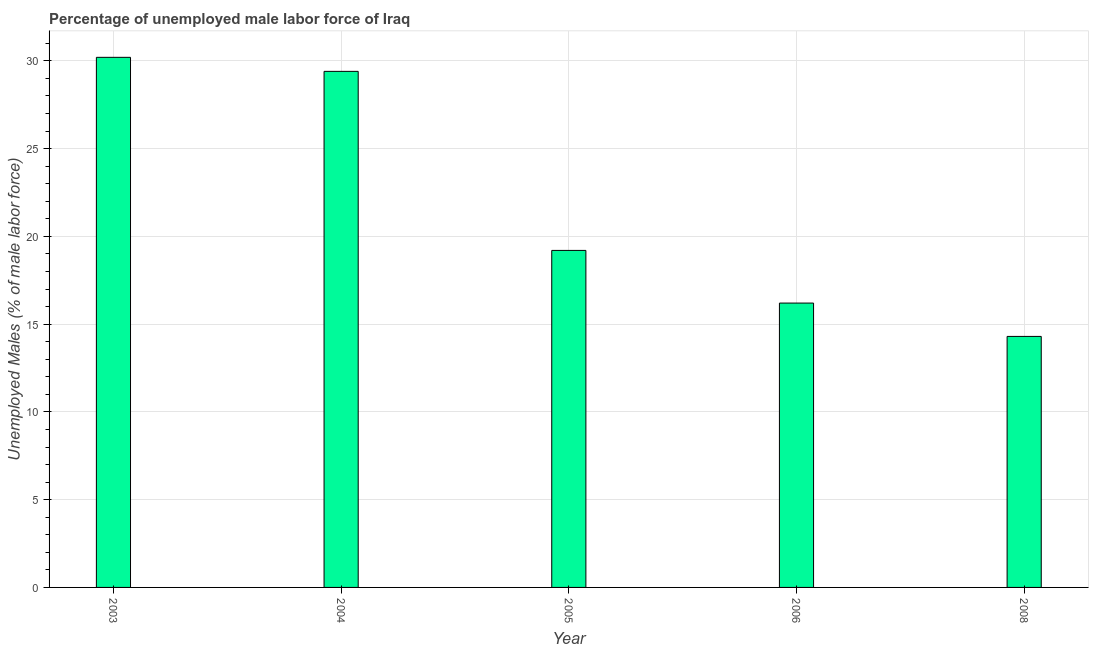Does the graph contain any zero values?
Offer a terse response. No. What is the title of the graph?
Provide a short and direct response. Percentage of unemployed male labor force of Iraq. What is the label or title of the Y-axis?
Ensure brevity in your answer.  Unemployed Males (% of male labor force). What is the total unemployed male labour force in 2006?
Provide a succinct answer. 16.2. Across all years, what is the maximum total unemployed male labour force?
Your answer should be compact. 30.2. Across all years, what is the minimum total unemployed male labour force?
Your response must be concise. 14.3. In which year was the total unemployed male labour force maximum?
Provide a succinct answer. 2003. What is the sum of the total unemployed male labour force?
Your answer should be compact. 109.3. What is the average total unemployed male labour force per year?
Your answer should be very brief. 21.86. What is the median total unemployed male labour force?
Provide a succinct answer. 19.2. What is the ratio of the total unemployed male labour force in 2004 to that in 2008?
Your answer should be very brief. 2.06. What is the difference between the highest and the second highest total unemployed male labour force?
Make the answer very short. 0.8. In how many years, is the total unemployed male labour force greater than the average total unemployed male labour force taken over all years?
Make the answer very short. 2. How many bars are there?
Your answer should be compact. 5. Are the values on the major ticks of Y-axis written in scientific E-notation?
Offer a very short reply. No. What is the Unemployed Males (% of male labor force) in 2003?
Provide a short and direct response. 30.2. What is the Unemployed Males (% of male labor force) in 2004?
Your answer should be compact. 29.4. What is the Unemployed Males (% of male labor force) in 2005?
Provide a succinct answer. 19.2. What is the Unemployed Males (% of male labor force) of 2006?
Make the answer very short. 16.2. What is the Unemployed Males (% of male labor force) of 2008?
Keep it short and to the point. 14.3. What is the difference between the Unemployed Males (% of male labor force) in 2003 and 2006?
Offer a terse response. 14. What is the difference between the Unemployed Males (% of male labor force) in 2004 and 2005?
Give a very brief answer. 10.2. What is the difference between the Unemployed Males (% of male labor force) in 2004 and 2006?
Give a very brief answer. 13.2. What is the difference between the Unemployed Males (% of male labor force) in 2004 and 2008?
Provide a short and direct response. 15.1. What is the difference between the Unemployed Males (% of male labor force) in 2005 and 2008?
Offer a very short reply. 4.9. What is the difference between the Unemployed Males (% of male labor force) in 2006 and 2008?
Make the answer very short. 1.9. What is the ratio of the Unemployed Males (% of male labor force) in 2003 to that in 2004?
Ensure brevity in your answer.  1.03. What is the ratio of the Unemployed Males (% of male labor force) in 2003 to that in 2005?
Your answer should be compact. 1.57. What is the ratio of the Unemployed Males (% of male labor force) in 2003 to that in 2006?
Your response must be concise. 1.86. What is the ratio of the Unemployed Males (% of male labor force) in 2003 to that in 2008?
Provide a short and direct response. 2.11. What is the ratio of the Unemployed Males (% of male labor force) in 2004 to that in 2005?
Ensure brevity in your answer.  1.53. What is the ratio of the Unemployed Males (% of male labor force) in 2004 to that in 2006?
Your answer should be very brief. 1.81. What is the ratio of the Unemployed Males (% of male labor force) in 2004 to that in 2008?
Your answer should be very brief. 2.06. What is the ratio of the Unemployed Males (% of male labor force) in 2005 to that in 2006?
Keep it short and to the point. 1.19. What is the ratio of the Unemployed Males (% of male labor force) in 2005 to that in 2008?
Provide a succinct answer. 1.34. What is the ratio of the Unemployed Males (% of male labor force) in 2006 to that in 2008?
Your answer should be compact. 1.13. 